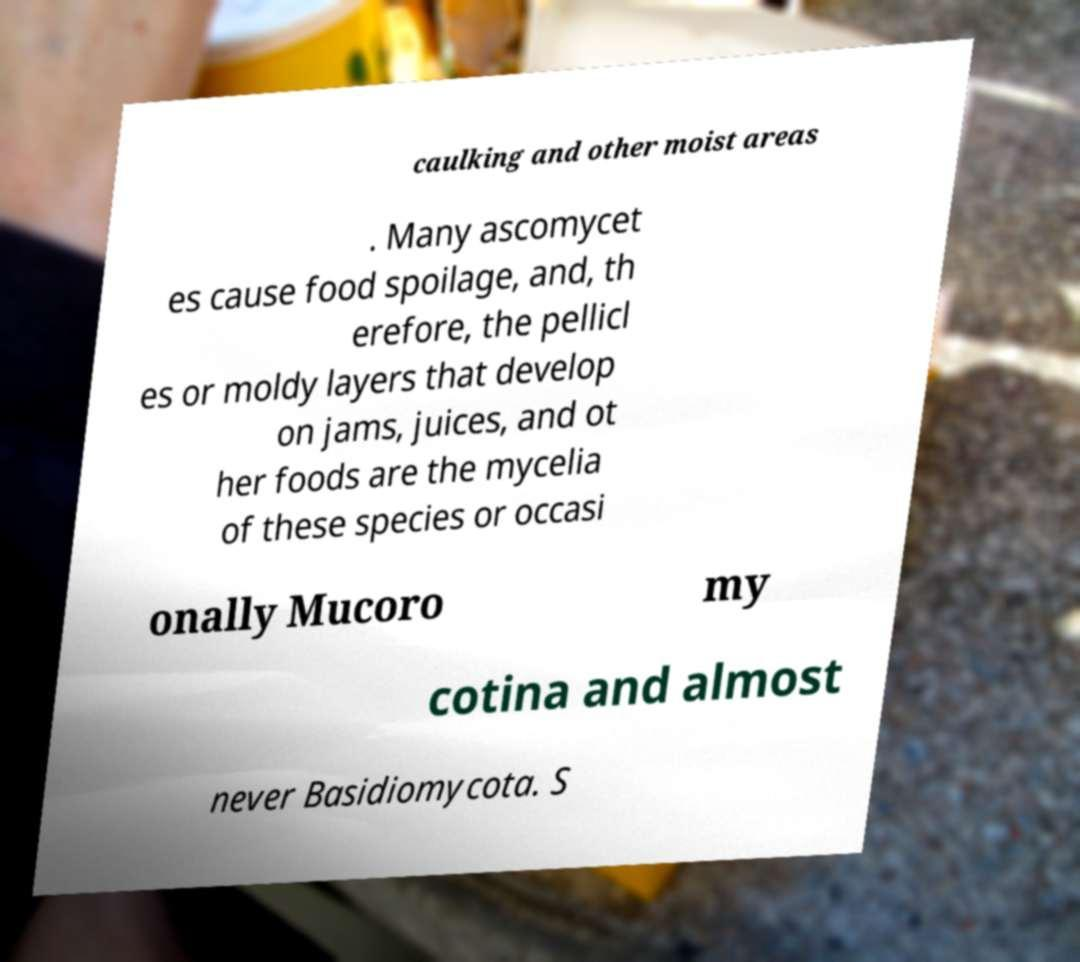Can you accurately transcribe the text from the provided image for me? caulking and other moist areas . Many ascomycet es cause food spoilage, and, th erefore, the pellicl es or moldy layers that develop on jams, juices, and ot her foods are the mycelia of these species or occasi onally Mucoro my cotina and almost never Basidiomycota. S 